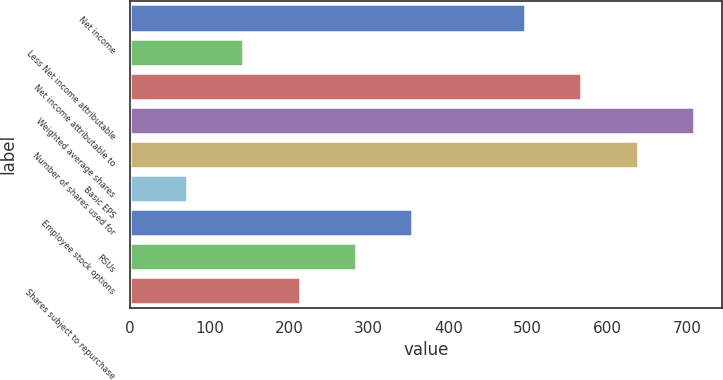<chart> <loc_0><loc_0><loc_500><loc_500><bar_chart><fcel>Net income<fcel>Less Net income attributable<fcel>Net income attributable to<fcel>Weighted average shares<fcel>Number of shares used for<fcel>Basic EPS<fcel>Employee stock options<fcel>RSUs<fcel>Shares subject to repurchase<nl><fcel>496.48<fcel>142.28<fcel>567.32<fcel>709<fcel>638.16<fcel>71.44<fcel>354.8<fcel>283.96<fcel>213.12<nl></chart> 